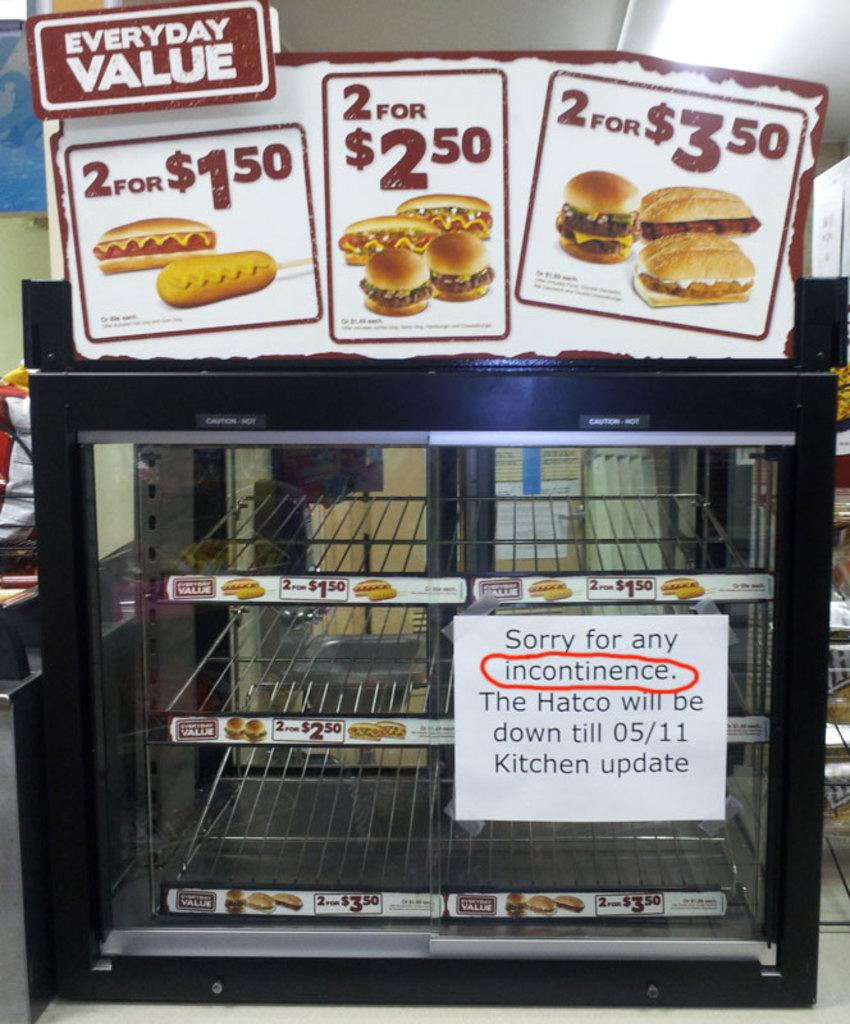<image>
Write a terse but informative summary of the picture. a small oven with a sign on it that says 'sorry for any incontinence' 